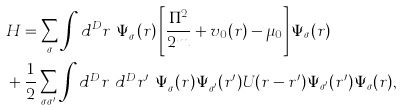Convert formula to latex. <formula><loc_0><loc_0><loc_500><loc_500>& H = \sum _ { \sigma } \int d ^ { D } r \ \Psi _ { \sigma } ^ { \dagger } ( { r } ) \left [ \frac { \Pi ^ { 2 } } { 2 m } + v _ { 0 } ( { r } ) - \mu _ { 0 } \right ] \Psi _ { \sigma } ( { r } ) \\ & + \frac { 1 } { 2 } \sum _ { \sigma \sigma ^ { \prime } } \int d ^ { D } r \ d ^ { D } r ^ { \prime } \ \Psi _ { \sigma } ^ { \dagger } ( { r } ) \Psi _ { \sigma ^ { \prime } } ^ { \dagger } ( { r ^ { \prime } } ) U ( { r } - { r ^ { \prime } } ) \Psi _ { \sigma ^ { \prime } } ( { r ^ { \prime } } ) \Psi _ { \sigma } ( { r } ) ,</formula> 